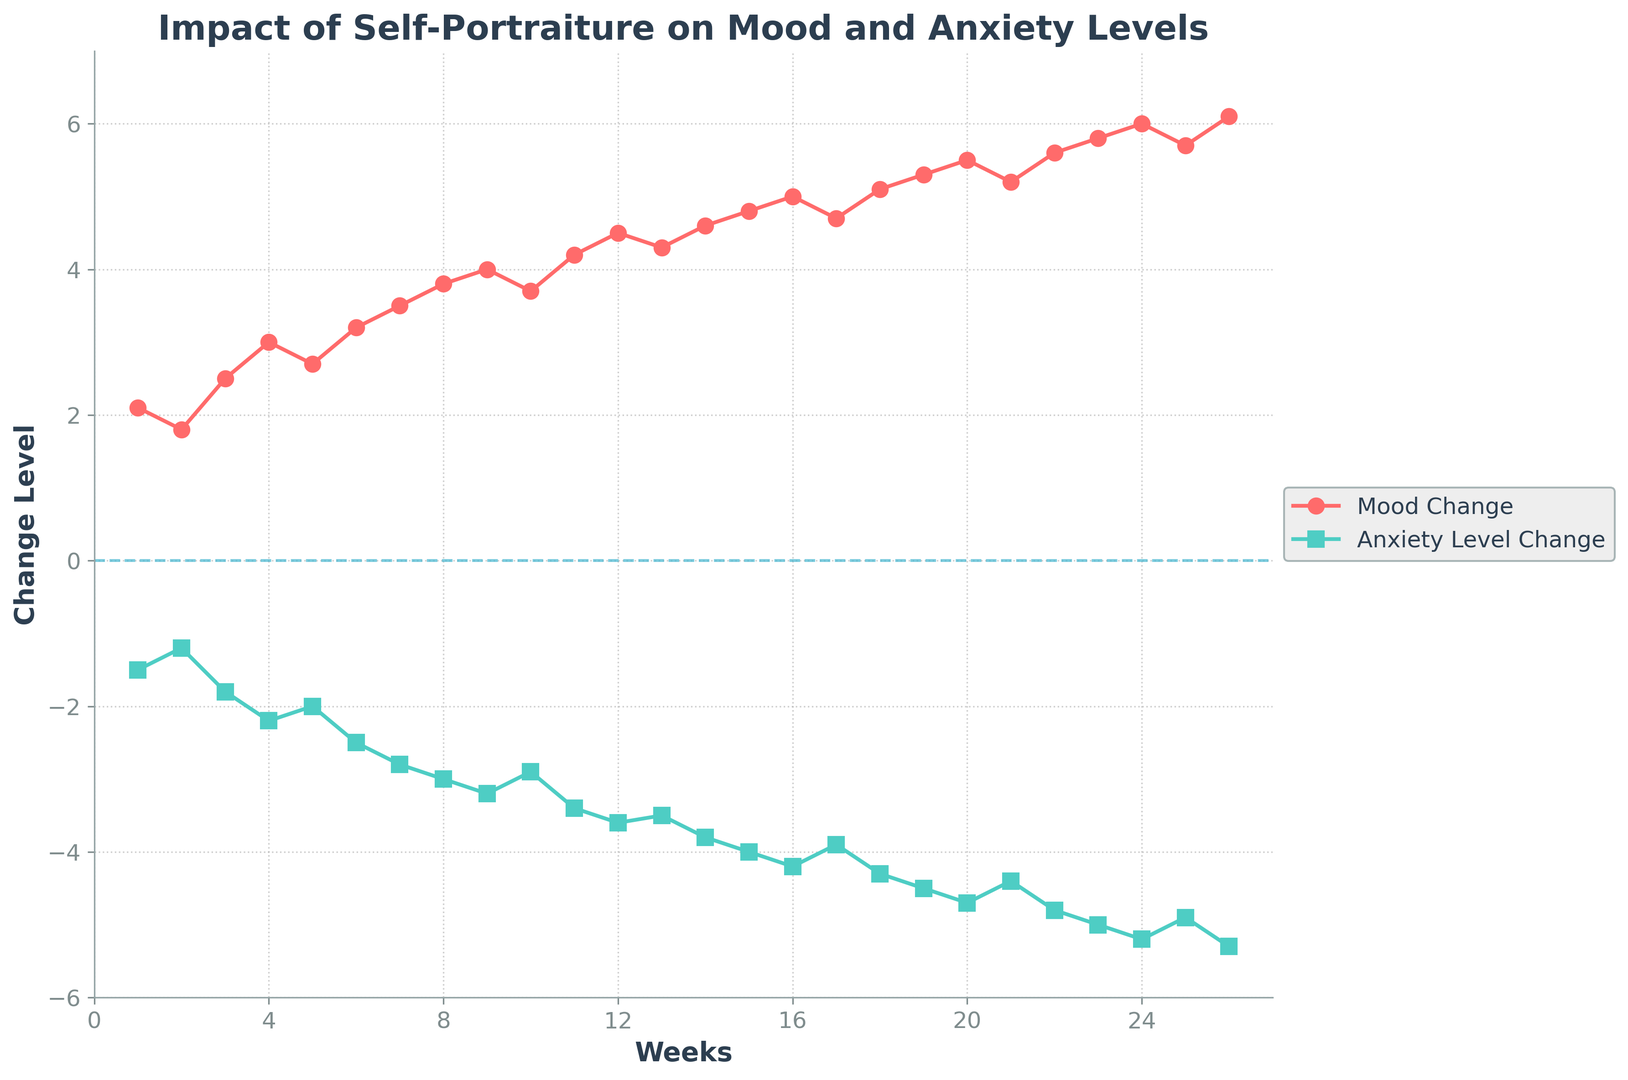What general trend can be observed in mood change over the 6 months? Observing the line representing mood change, it generally increases over the 6-month period, indicating a positive impact on mood as the weeks progress.
Answer: It increases How does the change in anxiety levels over the 6 months compare to the change in mood levels over the same period? The anxiety level change, represented by the cyan line, generally decreases over time, in contrast to the mood change, which increases.
Answer: Anxiety decreases At which weeks is the change in mood the highest? The change in mood is highest at Week 26, as observed by the peak of the red line representing mood change.
Answer: Week 26 Is there a week where both mood change and anxiety level change show a plateau or no significant change? Examining the data, Week 17 shows a small deviation in both mood and anxiety level changes, suggesting a possible plateau.
Answer: Week 17 What is the total change in anxiety levels from Week 1 to Week 26? To find the total change in anxiety levels, subtract the value at Week 1 (-1.5) from the value at Week 26 (-5.3). The total change is -5.3 - (-1.5) = -3.8.
Answer: -3.8 How does the mood change at Week 10 compare to the mood change at Week 15? At Week 10, the mood change is 3.7, and at Week 15, it is 4.8. Comparing these values, the mood change at Week 15 is 1.1 units higher than at Week 10.
Answer: 1.1 units higher Between which weeks does the mood change show the most rapid increase? Observing the slopes of the red line, the section between Week 22 and Week 23 shows the most rapid increase in mood change.
Answer: Week 22 to 23 What can be said about the overall relationship between mood change and anxiety level change? Overall, as mood change increases (positive), the anxiety level change decreases (negative), suggesting an inverse relationship.
Answer: Inverse relationship What is the difference in mood change between Week 1 and Week 26? The mood change at Week 1 is 2.1, and at Week 26, it is 6.1. The difference is 6.1 - 2.1 = 4.
Answer: 4 How does the change in anxiety levels from Week 12 to Week 14 compare? The anxiety level change at Week 12 is -3.6, and at Week 14, it is -3.8. The change from Week 12 to Week 14 is -3.8 - (-3.6) = -0.2 units.
Answer: -0.2 units 